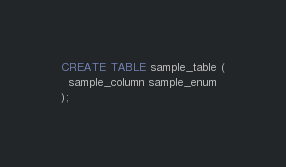Convert code to text. <code><loc_0><loc_0><loc_500><loc_500><_SQL_>
CREATE TABLE sample_table (
  sample_column sample_enum
);
</code> 